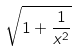Convert formula to latex. <formula><loc_0><loc_0><loc_500><loc_500>\sqrt { 1 + \frac { 1 } { x ^ { 2 } } }</formula> 